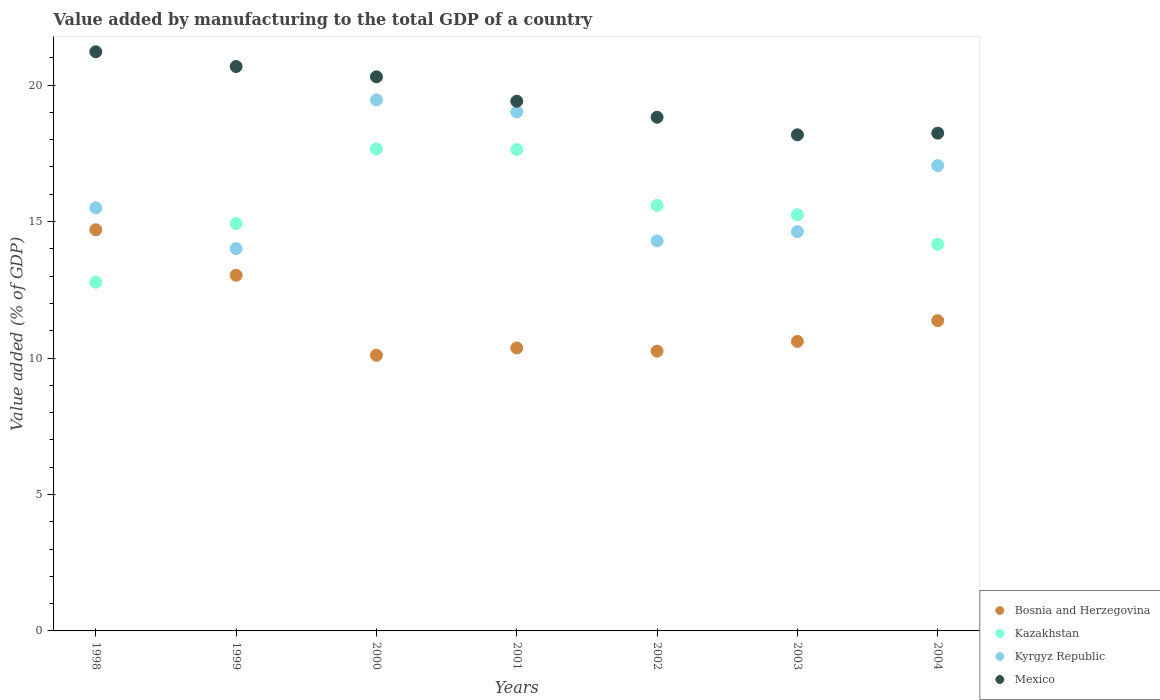What is the value added by manufacturing to the total GDP in Bosnia and Herzegovina in 2002?
Your answer should be very brief. 10.25. Across all years, what is the maximum value added by manufacturing to the total GDP in Bosnia and Herzegovina?
Provide a short and direct response. 14.7. Across all years, what is the minimum value added by manufacturing to the total GDP in Bosnia and Herzegovina?
Give a very brief answer. 10.1. In which year was the value added by manufacturing to the total GDP in Bosnia and Herzegovina maximum?
Provide a succinct answer. 1998. What is the total value added by manufacturing to the total GDP in Mexico in the graph?
Provide a succinct answer. 136.87. What is the difference between the value added by manufacturing to the total GDP in Mexico in 2000 and that in 2003?
Offer a terse response. 2.13. What is the difference between the value added by manufacturing to the total GDP in Bosnia and Herzegovina in 2003 and the value added by manufacturing to the total GDP in Kyrgyz Republic in 1999?
Ensure brevity in your answer.  -3.4. What is the average value added by manufacturing to the total GDP in Mexico per year?
Provide a succinct answer. 19.55. In the year 1998, what is the difference between the value added by manufacturing to the total GDP in Kyrgyz Republic and value added by manufacturing to the total GDP in Mexico?
Provide a succinct answer. -5.72. In how many years, is the value added by manufacturing to the total GDP in Kazakhstan greater than 1 %?
Your answer should be compact. 7. What is the ratio of the value added by manufacturing to the total GDP in Kyrgyz Republic in 2001 to that in 2003?
Offer a very short reply. 1.3. Is the value added by manufacturing to the total GDP in Kazakhstan in 1998 less than that in 2001?
Ensure brevity in your answer.  Yes. What is the difference between the highest and the second highest value added by manufacturing to the total GDP in Bosnia and Herzegovina?
Offer a terse response. 1.67. What is the difference between the highest and the lowest value added by manufacturing to the total GDP in Kyrgyz Republic?
Provide a succinct answer. 5.45. Is it the case that in every year, the sum of the value added by manufacturing to the total GDP in Mexico and value added by manufacturing to the total GDP in Bosnia and Herzegovina  is greater than the sum of value added by manufacturing to the total GDP in Kyrgyz Republic and value added by manufacturing to the total GDP in Kazakhstan?
Your response must be concise. No. Is the value added by manufacturing to the total GDP in Bosnia and Herzegovina strictly greater than the value added by manufacturing to the total GDP in Kazakhstan over the years?
Provide a succinct answer. No. What is the difference between two consecutive major ticks on the Y-axis?
Offer a terse response. 5. Are the values on the major ticks of Y-axis written in scientific E-notation?
Provide a short and direct response. No. Does the graph contain grids?
Your answer should be compact. No. Where does the legend appear in the graph?
Provide a short and direct response. Bottom right. How many legend labels are there?
Ensure brevity in your answer.  4. How are the legend labels stacked?
Provide a short and direct response. Vertical. What is the title of the graph?
Keep it short and to the point. Value added by manufacturing to the total GDP of a country. Does "Bahrain" appear as one of the legend labels in the graph?
Your answer should be compact. No. What is the label or title of the X-axis?
Give a very brief answer. Years. What is the label or title of the Y-axis?
Provide a succinct answer. Value added (% of GDP). What is the Value added (% of GDP) of Bosnia and Herzegovina in 1998?
Your answer should be very brief. 14.7. What is the Value added (% of GDP) in Kazakhstan in 1998?
Offer a terse response. 12.78. What is the Value added (% of GDP) in Kyrgyz Republic in 1998?
Provide a short and direct response. 15.5. What is the Value added (% of GDP) in Mexico in 1998?
Ensure brevity in your answer.  21.22. What is the Value added (% of GDP) in Bosnia and Herzegovina in 1999?
Offer a terse response. 13.03. What is the Value added (% of GDP) in Kazakhstan in 1999?
Your answer should be very brief. 14.93. What is the Value added (% of GDP) in Kyrgyz Republic in 1999?
Provide a short and direct response. 14.01. What is the Value added (% of GDP) of Mexico in 1999?
Ensure brevity in your answer.  20.68. What is the Value added (% of GDP) of Bosnia and Herzegovina in 2000?
Provide a short and direct response. 10.1. What is the Value added (% of GDP) of Kazakhstan in 2000?
Give a very brief answer. 17.66. What is the Value added (% of GDP) of Kyrgyz Republic in 2000?
Offer a very short reply. 19.46. What is the Value added (% of GDP) in Mexico in 2000?
Keep it short and to the point. 20.3. What is the Value added (% of GDP) of Bosnia and Herzegovina in 2001?
Give a very brief answer. 10.37. What is the Value added (% of GDP) of Kazakhstan in 2001?
Provide a succinct answer. 17.64. What is the Value added (% of GDP) of Kyrgyz Republic in 2001?
Give a very brief answer. 19.02. What is the Value added (% of GDP) in Mexico in 2001?
Provide a succinct answer. 19.41. What is the Value added (% of GDP) in Bosnia and Herzegovina in 2002?
Provide a short and direct response. 10.25. What is the Value added (% of GDP) in Kazakhstan in 2002?
Your answer should be compact. 15.59. What is the Value added (% of GDP) of Kyrgyz Republic in 2002?
Offer a terse response. 14.29. What is the Value added (% of GDP) in Mexico in 2002?
Provide a short and direct response. 18.82. What is the Value added (% of GDP) in Bosnia and Herzegovina in 2003?
Offer a terse response. 10.61. What is the Value added (% of GDP) in Kazakhstan in 2003?
Provide a succinct answer. 15.25. What is the Value added (% of GDP) in Kyrgyz Republic in 2003?
Offer a very short reply. 14.63. What is the Value added (% of GDP) in Mexico in 2003?
Give a very brief answer. 18.18. What is the Value added (% of GDP) of Bosnia and Herzegovina in 2004?
Ensure brevity in your answer.  11.37. What is the Value added (% of GDP) of Kazakhstan in 2004?
Your answer should be very brief. 14.17. What is the Value added (% of GDP) in Kyrgyz Republic in 2004?
Offer a very short reply. 17.05. What is the Value added (% of GDP) in Mexico in 2004?
Make the answer very short. 18.24. Across all years, what is the maximum Value added (% of GDP) in Bosnia and Herzegovina?
Provide a short and direct response. 14.7. Across all years, what is the maximum Value added (% of GDP) in Kazakhstan?
Make the answer very short. 17.66. Across all years, what is the maximum Value added (% of GDP) in Kyrgyz Republic?
Keep it short and to the point. 19.46. Across all years, what is the maximum Value added (% of GDP) of Mexico?
Keep it short and to the point. 21.22. Across all years, what is the minimum Value added (% of GDP) of Bosnia and Herzegovina?
Your answer should be compact. 10.1. Across all years, what is the minimum Value added (% of GDP) of Kazakhstan?
Provide a succinct answer. 12.78. Across all years, what is the minimum Value added (% of GDP) in Kyrgyz Republic?
Offer a terse response. 14.01. Across all years, what is the minimum Value added (% of GDP) in Mexico?
Your response must be concise. 18.18. What is the total Value added (% of GDP) of Bosnia and Herzegovina in the graph?
Ensure brevity in your answer.  80.43. What is the total Value added (% of GDP) of Kazakhstan in the graph?
Keep it short and to the point. 108.02. What is the total Value added (% of GDP) of Kyrgyz Republic in the graph?
Ensure brevity in your answer.  113.97. What is the total Value added (% of GDP) of Mexico in the graph?
Provide a short and direct response. 136.87. What is the difference between the Value added (% of GDP) in Bosnia and Herzegovina in 1998 and that in 1999?
Offer a very short reply. 1.67. What is the difference between the Value added (% of GDP) of Kazakhstan in 1998 and that in 1999?
Provide a succinct answer. -2.15. What is the difference between the Value added (% of GDP) of Kyrgyz Republic in 1998 and that in 1999?
Your answer should be very brief. 1.5. What is the difference between the Value added (% of GDP) of Mexico in 1998 and that in 1999?
Make the answer very short. 0.54. What is the difference between the Value added (% of GDP) of Bosnia and Herzegovina in 1998 and that in 2000?
Provide a succinct answer. 4.6. What is the difference between the Value added (% of GDP) in Kazakhstan in 1998 and that in 2000?
Your response must be concise. -4.88. What is the difference between the Value added (% of GDP) in Kyrgyz Republic in 1998 and that in 2000?
Give a very brief answer. -3.96. What is the difference between the Value added (% of GDP) of Mexico in 1998 and that in 2000?
Keep it short and to the point. 0.92. What is the difference between the Value added (% of GDP) of Bosnia and Herzegovina in 1998 and that in 2001?
Your answer should be very brief. 4.33. What is the difference between the Value added (% of GDP) of Kazakhstan in 1998 and that in 2001?
Ensure brevity in your answer.  -4.86. What is the difference between the Value added (% of GDP) in Kyrgyz Republic in 1998 and that in 2001?
Offer a terse response. -3.52. What is the difference between the Value added (% of GDP) in Mexico in 1998 and that in 2001?
Provide a succinct answer. 1.81. What is the difference between the Value added (% of GDP) of Bosnia and Herzegovina in 1998 and that in 2002?
Keep it short and to the point. 4.45. What is the difference between the Value added (% of GDP) of Kazakhstan in 1998 and that in 2002?
Offer a terse response. -2.82. What is the difference between the Value added (% of GDP) of Kyrgyz Republic in 1998 and that in 2002?
Make the answer very short. 1.21. What is the difference between the Value added (% of GDP) in Mexico in 1998 and that in 2002?
Your response must be concise. 2.4. What is the difference between the Value added (% of GDP) of Bosnia and Herzegovina in 1998 and that in 2003?
Give a very brief answer. 4.09. What is the difference between the Value added (% of GDP) of Kazakhstan in 1998 and that in 2003?
Your answer should be very brief. -2.48. What is the difference between the Value added (% of GDP) of Kyrgyz Republic in 1998 and that in 2003?
Offer a very short reply. 0.87. What is the difference between the Value added (% of GDP) of Mexico in 1998 and that in 2003?
Provide a succinct answer. 3.04. What is the difference between the Value added (% of GDP) of Bosnia and Herzegovina in 1998 and that in 2004?
Your response must be concise. 3.33. What is the difference between the Value added (% of GDP) in Kazakhstan in 1998 and that in 2004?
Your answer should be very brief. -1.39. What is the difference between the Value added (% of GDP) of Kyrgyz Republic in 1998 and that in 2004?
Your answer should be compact. -1.55. What is the difference between the Value added (% of GDP) in Mexico in 1998 and that in 2004?
Offer a very short reply. 2.98. What is the difference between the Value added (% of GDP) of Bosnia and Herzegovina in 1999 and that in 2000?
Make the answer very short. 2.93. What is the difference between the Value added (% of GDP) in Kazakhstan in 1999 and that in 2000?
Ensure brevity in your answer.  -2.73. What is the difference between the Value added (% of GDP) of Kyrgyz Republic in 1999 and that in 2000?
Offer a very short reply. -5.45. What is the difference between the Value added (% of GDP) of Mexico in 1999 and that in 2000?
Your answer should be very brief. 0.38. What is the difference between the Value added (% of GDP) in Bosnia and Herzegovina in 1999 and that in 2001?
Provide a short and direct response. 2.66. What is the difference between the Value added (% of GDP) in Kazakhstan in 1999 and that in 2001?
Your answer should be very brief. -2.71. What is the difference between the Value added (% of GDP) in Kyrgyz Republic in 1999 and that in 2001?
Offer a very short reply. -5.01. What is the difference between the Value added (% of GDP) of Mexico in 1999 and that in 2001?
Provide a short and direct response. 1.27. What is the difference between the Value added (% of GDP) of Bosnia and Herzegovina in 1999 and that in 2002?
Your response must be concise. 2.78. What is the difference between the Value added (% of GDP) of Kazakhstan in 1999 and that in 2002?
Make the answer very short. -0.67. What is the difference between the Value added (% of GDP) of Kyrgyz Republic in 1999 and that in 2002?
Give a very brief answer. -0.28. What is the difference between the Value added (% of GDP) in Mexico in 1999 and that in 2002?
Your answer should be compact. 1.86. What is the difference between the Value added (% of GDP) in Bosnia and Herzegovina in 1999 and that in 2003?
Provide a succinct answer. 2.42. What is the difference between the Value added (% of GDP) of Kazakhstan in 1999 and that in 2003?
Provide a short and direct response. -0.32. What is the difference between the Value added (% of GDP) in Kyrgyz Republic in 1999 and that in 2003?
Provide a short and direct response. -0.62. What is the difference between the Value added (% of GDP) in Mexico in 1999 and that in 2003?
Keep it short and to the point. 2.5. What is the difference between the Value added (% of GDP) in Bosnia and Herzegovina in 1999 and that in 2004?
Provide a short and direct response. 1.66. What is the difference between the Value added (% of GDP) of Kazakhstan in 1999 and that in 2004?
Ensure brevity in your answer.  0.76. What is the difference between the Value added (% of GDP) of Kyrgyz Republic in 1999 and that in 2004?
Offer a terse response. -3.04. What is the difference between the Value added (% of GDP) in Mexico in 1999 and that in 2004?
Ensure brevity in your answer.  2.44. What is the difference between the Value added (% of GDP) in Bosnia and Herzegovina in 2000 and that in 2001?
Make the answer very short. -0.27. What is the difference between the Value added (% of GDP) of Kazakhstan in 2000 and that in 2001?
Provide a short and direct response. 0.02. What is the difference between the Value added (% of GDP) in Kyrgyz Republic in 2000 and that in 2001?
Ensure brevity in your answer.  0.44. What is the difference between the Value added (% of GDP) in Mexico in 2000 and that in 2001?
Your response must be concise. 0.89. What is the difference between the Value added (% of GDP) of Bosnia and Herzegovina in 2000 and that in 2002?
Provide a short and direct response. -0.15. What is the difference between the Value added (% of GDP) of Kazakhstan in 2000 and that in 2002?
Provide a short and direct response. 2.07. What is the difference between the Value added (% of GDP) in Kyrgyz Republic in 2000 and that in 2002?
Ensure brevity in your answer.  5.17. What is the difference between the Value added (% of GDP) of Mexico in 2000 and that in 2002?
Your answer should be very brief. 1.48. What is the difference between the Value added (% of GDP) in Bosnia and Herzegovina in 2000 and that in 2003?
Ensure brevity in your answer.  -0.51. What is the difference between the Value added (% of GDP) of Kazakhstan in 2000 and that in 2003?
Make the answer very short. 2.41. What is the difference between the Value added (% of GDP) of Kyrgyz Republic in 2000 and that in 2003?
Your answer should be very brief. 4.83. What is the difference between the Value added (% of GDP) of Mexico in 2000 and that in 2003?
Provide a succinct answer. 2.13. What is the difference between the Value added (% of GDP) in Bosnia and Herzegovina in 2000 and that in 2004?
Offer a very short reply. -1.27. What is the difference between the Value added (% of GDP) of Kazakhstan in 2000 and that in 2004?
Make the answer very short. 3.49. What is the difference between the Value added (% of GDP) of Kyrgyz Republic in 2000 and that in 2004?
Your response must be concise. 2.41. What is the difference between the Value added (% of GDP) of Mexico in 2000 and that in 2004?
Offer a very short reply. 2.06. What is the difference between the Value added (% of GDP) in Bosnia and Herzegovina in 2001 and that in 2002?
Offer a very short reply. 0.12. What is the difference between the Value added (% of GDP) in Kazakhstan in 2001 and that in 2002?
Keep it short and to the point. 2.04. What is the difference between the Value added (% of GDP) in Kyrgyz Republic in 2001 and that in 2002?
Offer a terse response. 4.73. What is the difference between the Value added (% of GDP) of Mexico in 2001 and that in 2002?
Provide a succinct answer. 0.59. What is the difference between the Value added (% of GDP) of Bosnia and Herzegovina in 2001 and that in 2003?
Your response must be concise. -0.24. What is the difference between the Value added (% of GDP) in Kazakhstan in 2001 and that in 2003?
Offer a terse response. 2.39. What is the difference between the Value added (% of GDP) in Kyrgyz Republic in 2001 and that in 2003?
Provide a short and direct response. 4.39. What is the difference between the Value added (% of GDP) in Mexico in 2001 and that in 2003?
Make the answer very short. 1.23. What is the difference between the Value added (% of GDP) of Bosnia and Herzegovina in 2001 and that in 2004?
Ensure brevity in your answer.  -1. What is the difference between the Value added (% of GDP) in Kazakhstan in 2001 and that in 2004?
Your answer should be very brief. 3.47. What is the difference between the Value added (% of GDP) in Kyrgyz Republic in 2001 and that in 2004?
Your answer should be compact. 1.97. What is the difference between the Value added (% of GDP) in Mexico in 2001 and that in 2004?
Make the answer very short. 1.17. What is the difference between the Value added (% of GDP) in Bosnia and Herzegovina in 2002 and that in 2003?
Offer a terse response. -0.36. What is the difference between the Value added (% of GDP) of Kazakhstan in 2002 and that in 2003?
Keep it short and to the point. 0.34. What is the difference between the Value added (% of GDP) of Kyrgyz Republic in 2002 and that in 2003?
Provide a succinct answer. -0.34. What is the difference between the Value added (% of GDP) in Mexico in 2002 and that in 2003?
Your answer should be very brief. 0.64. What is the difference between the Value added (% of GDP) of Bosnia and Herzegovina in 2002 and that in 2004?
Ensure brevity in your answer.  -1.12. What is the difference between the Value added (% of GDP) in Kazakhstan in 2002 and that in 2004?
Offer a terse response. 1.43. What is the difference between the Value added (% of GDP) of Kyrgyz Republic in 2002 and that in 2004?
Provide a short and direct response. -2.76. What is the difference between the Value added (% of GDP) of Mexico in 2002 and that in 2004?
Ensure brevity in your answer.  0.58. What is the difference between the Value added (% of GDP) in Bosnia and Herzegovina in 2003 and that in 2004?
Keep it short and to the point. -0.76. What is the difference between the Value added (% of GDP) of Kazakhstan in 2003 and that in 2004?
Provide a short and direct response. 1.09. What is the difference between the Value added (% of GDP) of Kyrgyz Republic in 2003 and that in 2004?
Make the answer very short. -2.42. What is the difference between the Value added (% of GDP) of Mexico in 2003 and that in 2004?
Your answer should be compact. -0.06. What is the difference between the Value added (% of GDP) in Bosnia and Herzegovina in 1998 and the Value added (% of GDP) in Kazakhstan in 1999?
Your response must be concise. -0.23. What is the difference between the Value added (% of GDP) of Bosnia and Herzegovina in 1998 and the Value added (% of GDP) of Kyrgyz Republic in 1999?
Give a very brief answer. 0.69. What is the difference between the Value added (% of GDP) in Bosnia and Herzegovina in 1998 and the Value added (% of GDP) in Mexico in 1999?
Make the answer very short. -5.98. What is the difference between the Value added (% of GDP) of Kazakhstan in 1998 and the Value added (% of GDP) of Kyrgyz Republic in 1999?
Make the answer very short. -1.23. What is the difference between the Value added (% of GDP) in Kazakhstan in 1998 and the Value added (% of GDP) in Mexico in 1999?
Provide a succinct answer. -7.91. What is the difference between the Value added (% of GDP) in Kyrgyz Republic in 1998 and the Value added (% of GDP) in Mexico in 1999?
Your response must be concise. -5.18. What is the difference between the Value added (% of GDP) of Bosnia and Herzegovina in 1998 and the Value added (% of GDP) of Kazakhstan in 2000?
Provide a succinct answer. -2.96. What is the difference between the Value added (% of GDP) of Bosnia and Herzegovina in 1998 and the Value added (% of GDP) of Kyrgyz Republic in 2000?
Your response must be concise. -4.76. What is the difference between the Value added (% of GDP) of Bosnia and Herzegovina in 1998 and the Value added (% of GDP) of Mexico in 2000?
Offer a very short reply. -5.6. What is the difference between the Value added (% of GDP) of Kazakhstan in 1998 and the Value added (% of GDP) of Kyrgyz Republic in 2000?
Your answer should be compact. -6.68. What is the difference between the Value added (% of GDP) of Kazakhstan in 1998 and the Value added (% of GDP) of Mexico in 2000?
Ensure brevity in your answer.  -7.53. What is the difference between the Value added (% of GDP) of Kyrgyz Republic in 1998 and the Value added (% of GDP) of Mexico in 2000?
Provide a succinct answer. -4.8. What is the difference between the Value added (% of GDP) in Bosnia and Herzegovina in 1998 and the Value added (% of GDP) in Kazakhstan in 2001?
Provide a short and direct response. -2.94. What is the difference between the Value added (% of GDP) in Bosnia and Herzegovina in 1998 and the Value added (% of GDP) in Kyrgyz Republic in 2001?
Offer a terse response. -4.32. What is the difference between the Value added (% of GDP) in Bosnia and Herzegovina in 1998 and the Value added (% of GDP) in Mexico in 2001?
Your response must be concise. -4.71. What is the difference between the Value added (% of GDP) in Kazakhstan in 1998 and the Value added (% of GDP) in Kyrgyz Republic in 2001?
Your answer should be compact. -6.24. What is the difference between the Value added (% of GDP) in Kazakhstan in 1998 and the Value added (% of GDP) in Mexico in 2001?
Keep it short and to the point. -6.63. What is the difference between the Value added (% of GDP) of Kyrgyz Republic in 1998 and the Value added (% of GDP) of Mexico in 2001?
Keep it short and to the point. -3.91. What is the difference between the Value added (% of GDP) in Bosnia and Herzegovina in 1998 and the Value added (% of GDP) in Kazakhstan in 2002?
Provide a succinct answer. -0.89. What is the difference between the Value added (% of GDP) in Bosnia and Herzegovina in 1998 and the Value added (% of GDP) in Kyrgyz Republic in 2002?
Offer a very short reply. 0.41. What is the difference between the Value added (% of GDP) of Bosnia and Herzegovina in 1998 and the Value added (% of GDP) of Mexico in 2002?
Your response must be concise. -4.12. What is the difference between the Value added (% of GDP) in Kazakhstan in 1998 and the Value added (% of GDP) in Kyrgyz Republic in 2002?
Your answer should be compact. -1.51. What is the difference between the Value added (% of GDP) in Kazakhstan in 1998 and the Value added (% of GDP) in Mexico in 2002?
Your answer should be compact. -6.05. What is the difference between the Value added (% of GDP) of Kyrgyz Republic in 1998 and the Value added (% of GDP) of Mexico in 2002?
Make the answer very short. -3.32. What is the difference between the Value added (% of GDP) in Bosnia and Herzegovina in 1998 and the Value added (% of GDP) in Kazakhstan in 2003?
Make the answer very short. -0.55. What is the difference between the Value added (% of GDP) in Bosnia and Herzegovina in 1998 and the Value added (% of GDP) in Kyrgyz Republic in 2003?
Your response must be concise. 0.07. What is the difference between the Value added (% of GDP) in Bosnia and Herzegovina in 1998 and the Value added (% of GDP) in Mexico in 2003?
Make the answer very short. -3.48. What is the difference between the Value added (% of GDP) of Kazakhstan in 1998 and the Value added (% of GDP) of Kyrgyz Republic in 2003?
Keep it short and to the point. -1.86. What is the difference between the Value added (% of GDP) in Kazakhstan in 1998 and the Value added (% of GDP) in Mexico in 2003?
Offer a terse response. -5.4. What is the difference between the Value added (% of GDP) in Kyrgyz Republic in 1998 and the Value added (% of GDP) in Mexico in 2003?
Your answer should be very brief. -2.68. What is the difference between the Value added (% of GDP) in Bosnia and Herzegovina in 1998 and the Value added (% of GDP) in Kazakhstan in 2004?
Make the answer very short. 0.53. What is the difference between the Value added (% of GDP) of Bosnia and Herzegovina in 1998 and the Value added (% of GDP) of Kyrgyz Republic in 2004?
Give a very brief answer. -2.35. What is the difference between the Value added (% of GDP) in Bosnia and Herzegovina in 1998 and the Value added (% of GDP) in Mexico in 2004?
Your answer should be very brief. -3.54. What is the difference between the Value added (% of GDP) in Kazakhstan in 1998 and the Value added (% of GDP) in Kyrgyz Republic in 2004?
Offer a terse response. -4.28. What is the difference between the Value added (% of GDP) in Kazakhstan in 1998 and the Value added (% of GDP) in Mexico in 2004?
Offer a terse response. -5.46. What is the difference between the Value added (% of GDP) in Kyrgyz Republic in 1998 and the Value added (% of GDP) in Mexico in 2004?
Provide a short and direct response. -2.74. What is the difference between the Value added (% of GDP) in Bosnia and Herzegovina in 1999 and the Value added (% of GDP) in Kazakhstan in 2000?
Keep it short and to the point. -4.63. What is the difference between the Value added (% of GDP) of Bosnia and Herzegovina in 1999 and the Value added (% of GDP) of Kyrgyz Republic in 2000?
Provide a succinct answer. -6.43. What is the difference between the Value added (% of GDP) of Bosnia and Herzegovina in 1999 and the Value added (% of GDP) of Mexico in 2000?
Your answer should be very brief. -7.27. What is the difference between the Value added (% of GDP) of Kazakhstan in 1999 and the Value added (% of GDP) of Kyrgyz Republic in 2000?
Provide a short and direct response. -4.53. What is the difference between the Value added (% of GDP) of Kazakhstan in 1999 and the Value added (% of GDP) of Mexico in 2000?
Keep it short and to the point. -5.38. What is the difference between the Value added (% of GDP) of Kyrgyz Republic in 1999 and the Value added (% of GDP) of Mexico in 2000?
Provide a short and direct response. -6.3. What is the difference between the Value added (% of GDP) of Bosnia and Herzegovina in 1999 and the Value added (% of GDP) of Kazakhstan in 2001?
Your response must be concise. -4.61. What is the difference between the Value added (% of GDP) in Bosnia and Herzegovina in 1999 and the Value added (% of GDP) in Kyrgyz Republic in 2001?
Make the answer very short. -5.99. What is the difference between the Value added (% of GDP) of Bosnia and Herzegovina in 1999 and the Value added (% of GDP) of Mexico in 2001?
Give a very brief answer. -6.38. What is the difference between the Value added (% of GDP) in Kazakhstan in 1999 and the Value added (% of GDP) in Kyrgyz Republic in 2001?
Your answer should be very brief. -4.09. What is the difference between the Value added (% of GDP) of Kazakhstan in 1999 and the Value added (% of GDP) of Mexico in 2001?
Your answer should be compact. -4.48. What is the difference between the Value added (% of GDP) of Kyrgyz Republic in 1999 and the Value added (% of GDP) of Mexico in 2001?
Give a very brief answer. -5.4. What is the difference between the Value added (% of GDP) of Bosnia and Herzegovina in 1999 and the Value added (% of GDP) of Kazakhstan in 2002?
Offer a very short reply. -2.56. What is the difference between the Value added (% of GDP) in Bosnia and Herzegovina in 1999 and the Value added (% of GDP) in Kyrgyz Republic in 2002?
Provide a short and direct response. -1.26. What is the difference between the Value added (% of GDP) in Bosnia and Herzegovina in 1999 and the Value added (% of GDP) in Mexico in 2002?
Keep it short and to the point. -5.79. What is the difference between the Value added (% of GDP) of Kazakhstan in 1999 and the Value added (% of GDP) of Kyrgyz Republic in 2002?
Provide a short and direct response. 0.64. What is the difference between the Value added (% of GDP) of Kazakhstan in 1999 and the Value added (% of GDP) of Mexico in 2002?
Provide a succinct answer. -3.89. What is the difference between the Value added (% of GDP) of Kyrgyz Republic in 1999 and the Value added (% of GDP) of Mexico in 2002?
Your response must be concise. -4.82. What is the difference between the Value added (% of GDP) of Bosnia and Herzegovina in 1999 and the Value added (% of GDP) of Kazakhstan in 2003?
Your answer should be compact. -2.22. What is the difference between the Value added (% of GDP) of Bosnia and Herzegovina in 1999 and the Value added (% of GDP) of Kyrgyz Republic in 2003?
Keep it short and to the point. -1.6. What is the difference between the Value added (% of GDP) of Bosnia and Herzegovina in 1999 and the Value added (% of GDP) of Mexico in 2003?
Your answer should be compact. -5.15. What is the difference between the Value added (% of GDP) in Kazakhstan in 1999 and the Value added (% of GDP) in Kyrgyz Republic in 2003?
Offer a terse response. 0.3. What is the difference between the Value added (% of GDP) of Kazakhstan in 1999 and the Value added (% of GDP) of Mexico in 2003?
Make the answer very short. -3.25. What is the difference between the Value added (% of GDP) in Kyrgyz Republic in 1999 and the Value added (% of GDP) in Mexico in 2003?
Offer a terse response. -4.17. What is the difference between the Value added (% of GDP) of Bosnia and Herzegovina in 1999 and the Value added (% of GDP) of Kazakhstan in 2004?
Keep it short and to the point. -1.13. What is the difference between the Value added (% of GDP) in Bosnia and Herzegovina in 1999 and the Value added (% of GDP) in Kyrgyz Republic in 2004?
Keep it short and to the point. -4.02. What is the difference between the Value added (% of GDP) of Bosnia and Herzegovina in 1999 and the Value added (% of GDP) of Mexico in 2004?
Offer a terse response. -5.21. What is the difference between the Value added (% of GDP) of Kazakhstan in 1999 and the Value added (% of GDP) of Kyrgyz Republic in 2004?
Offer a terse response. -2.12. What is the difference between the Value added (% of GDP) of Kazakhstan in 1999 and the Value added (% of GDP) of Mexico in 2004?
Give a very brief answer. -3.31. What is the difference between the Value added (% of GDP) in Kyrgyz Republic in 1999 and the Value added (% of GDP) in Mexico in 2004?
Ensure brevity in your answer.  -4.23. What is the difference between the Value added (% of GDP) of Bosnia and Herzegovina in 2000 and the Value added (% of GDP) of Kazakhstan in 2001?
Make the answer very short. -7.54. What is the difference between the Value added (% of GDP) in Bosnia and Herzegovina in 2000 and the Value added (% of GDP) in Kyrgyz Republic in 2001?
Ensure brevity in your answer.  -8.92. What is the difference between the Value added (% of GDP) in Bosnia and Herzegovina in 2000 and the Value added (% of GDP) in Mexico in 2001?
Ensure brevity in your answer.  -9.31. What is the difference between the Value added (% of GDP) in Kazakhstan in 2000 and the Value added (% of GDP) in Kyrgyz Republic in 2001?
Your response must be concise. -1.36. What is the difference between the Value added (% of GDP) of Kazakhstan in 2000 and the Value added (% of GDP) of Mexico in 2001?
Provide a short and direct response. -1.75. What is the difference between the Value added (% of GDP) in Kyrgyz Republic in 2000 and the Value added (% of GDP) in Mexico in 2001?
Your answer should be very brief. 0.05. What is the difference between the Value added (% of GDP) of Bosnia and Herzegovina in 2000 and the Value added (% of GDP) of Kazakhstan in 2002?
Provide a succinct answer. -5.49. What is the difference between the Value added (% of GDP) of Bosnia and Herzegovina in 2000 and the Value added (% of GDP) of Kyrgyz Republic in 2002?
Offer a terse response. -4.19. What is the difference between the Value added (% of GDP) in Bosnia and Herzegovina in 2000 and the Value added (% of GDP) in Mexico in 2002?
Your response must be concise. -8.72. What is the difference between the Value added (% of GDP) in Kazakhstan in 2000 and the Value added (% of GDP) in Kyrgyz Republic in 2002?
Provide a succinct answer. 3.37. What is the difference between the Value added (% of GDP) in Kazakhstan in 2000 and the Value added (% of GDP) in Mexico in 2002?
Provide a short and direct response. -1.16. What is the difference between the Value added (% of GDP) of Kyrgyz Republic in 2000 and the Value added (% of GDP) of Mexico in 2002?
Provide a succinct answer. 0.63. What is the difference between the Value added (% of GDP) in Bosnia and Herzegovina in 2000 and the Value added (% of GDP) in Kazakhstan in 2003?
Offer a very short reply. -5.15. What is the difference between the Value added (% of GDP) in Bosnia and Herzegovina in 2000 and the Value added (% of GDP) in Kyrgyz Republic in 2003?
Provide a succinct answer. -4.53. What is the difference between the Value added (% of GDP) in Bosnia and Herzegovina in 2000 and the Value added (% of GDP) in Mexico in 2003?
Provide a succinct answer. -8.08. What is the difference between the Value added (% of GDP) in Kazakhstan in 2000 and the Value added (% of GDP) in Kyrgyz Republic in 2003?
Your answer should be very brief. 3.03. What is the difference between the Value added (% of GDP) in Kazakhstan in 2000 and the Value added (% of GDP) in Mexico in 2003?
Offer a very short reply. -0.52. What is the difference between the Value added (% of GDP) in Kyrgyz Republic in 2000 and the Value added (% of GDP) in Mexico in 2003?
Give a very brief answer. 1.28. What is the difference between the Value added (% of GDP) of Bosnia and Herzegovina in 2000 and the Value added (% of GDP) of Kazakhstan in 2004?
Provide a short and direct response. -4.07. What is the difference between the Value added (% of GDP) of Bosnia and Herzegovina in 2000 and the Value added (% of GDP) of Kyrgyz Republic in 2004?
Ensure brevity in your answer.  -6.95. What is the difference between the Value added (% of GDP) in Bosnia and Herzegovina in 2000 and the Value added (% of GDP) in Mexico in 2004?
Make the answer very short. -8.14. What is the difference between the Value added (% of GDP) of Kazakhstan in 2000 and the Value added (% of GDP) of Kyrgyz Republic in 2004?
Give a very brief answer. 0.61. What is the difference between the Value added (% of GDP) in Kazakhstan in 2000 and the Value added (% of GDP) in Mexico in 2004?
Provide a short and direct response. -0.58. What is the difference between the Value added (% of GDP) in Kyrgyz Republic in 2000 and the Value added (% of GDP) in Mexico in 2004?
Offer a very short reply. 1.22. What is the difference between the Value added (% of GDP) in Bosnia and Herzegovina in 2001 and the Value added (% of GDP) in Kazakhstan in 2002?
Your answer should be very brief. -5.23. What is the difference between the Value added (% of GDP) in Bosnia and Herzegovina in 2001 and the Value added (% of GDP) in Kyrgyz Republic in 2002?
Make the answer very short. -3.92. What is the difference between the Value added (% of GDP) of Bosnia and Herzegovina in 2001 and the Value added (% of GDP) of Mexico in 2002?
Your answer should be compact. -8.46. What is the difference between the Value added (% of GDP) in Kazakhstan in 2001 and the Value added (% of GDP) in Kyrgyz Republic in 2002?
Make the answer very short. 3.35. What is the difference between the Value added (% of GDP) of Kazakhstan in 2001 and the Value added (% of GDP) of Mexico in 2002?
Offer a terse response. -1.18. What is the difference between the Value added (% of GDP) of Kyrgyz Republic in 2001 and the Value added (% of GDP) of Mexico in 2002?
Your answer should be very brief. 0.2. What is the difference between the Value added (% of GDP) of Bosnia and Herzegovina in 2001 and the Value added (% of GDP) of Kazakhstan in 2003?
Offer a very short reply. -4.88. What is the difference between the Value added (% of GDP) in Bosnia and Herzegovina in 2001 and the Value added (% of GDP) in Kyrgyz Republic in 2003?
Your response must be concise. -4.27. What is the difference between the Value added (% of GDP) of Bosnia and Herzegovina in 2001 and the Value added (% of GDP) of Mexico in 2003?
Your answer should be very brief. -7.81. What is the difference between the Value added (% of GDP) in Kazakhstan in 2001 and the Value added (% of GDP) in Kyrgyz Republic in 2003?
Your answer should be compact. 3.01. What is the difference between the Value added (% of GDP) of Kazakhstan in 2001 and the Value added (% of GDP) of Mexico in 2003?
Your response must be concise. -0.54. What is the difference between the Value added (% of GDP) of Kyrgyz Republic in 2001 and the Value added (% of GDP) of Mexico in 2003?
Keep it short and to the point. 0.84. What is the difference between the Value added (% of GDP) of Bosnia and Herzegovina in 2001 and the Value added (% of GDP) of Kazakhstan in 2004?
Your answer should be very brief. -3.8. What is the difference between the Value added (% of GDP) in Bosnia and Herzegovina in 2001 and the Value added (% of GDP) in Kyrgyz Republic in 2004?
Ensure brevity in your answer.  -6.68. What is the difference between the Value added (% of GDP) of Bosnia and Herzegovina in 2001 and the Value added (% of GDP) of Mexico in 2004?
Make the answer very short. -7.87. What is the difference between the Value added (% of GDP) of Kazakhstan in 2001 and the Value added (% of GDP) of Kyrgyz Republic in 2004?
Keep it short and to the point. 0.59. What is the difference between the Value added (% of GDP) in Kazakhstan in 2001 and the Value added (% of GDP) in Mexico in 2004?
Keep it short and to the point. -0.6. What is the difference between the Value added (% of GDP) of Kyrgyz Republic in 2001 and the Value added (% of GDP) of Mexico in 2004?
Your answer should be compact. 0.78. What is the difference between the Value added (% of GDP) in Bosnia and Herzegovina in 2002 and the Value added (% of GDP) in Kazakhstan in 2003?
Ensure brevity in your answer.  -5. What is the difference between the Value added (% of GDP) in Bosnia and Herzegovina in 2002 and the Value added (% of GDP) in Kyrgyz Republic in 2003?
Give a very brief answer. -4.38. What is the difference between the Value added (% of GDP) in Bosnia and Herzegovina in 2002 and the Value added (% of GDP) in Mexico in 2003?
Provide a short and direct response. -7.93. What is the difference between the Value added (% of GDP) in Kazakhstan in 2002 and the Value added (% of GDP) in Kyrgyz Republic in 2003?
Your response must be concise. 0.96. What is the difference between the Value added (% of GDP) of Kazakhstan in 2002 and the Value added (% of GDP) of Mexico in 2003?
Give a very brief answer. -2.58. What is the difference between the Value added (% of GDP) in Kyrgyz Republic in 2002 and the Value added (% of GDP) in Mexico in 2003?
Keep it short and to the point. -3.89. What is the difference between the Value added (% of GDP) of Bosnia and Herzegovina in 2002 and the Value added (% of GDP) of Kazakhstan in 2004?
Give a very brief answer. -3.92. What is the difference between the Value added (% of GDP) in Bosnia and Herzegovina in 2002 and the Value added (% of GDP) in Kyrgyz Republic in 2004?
Provide a short and direct response. -6.8. What is the difference between the Value added (% of GDP) of Bosnia and Herzegovina in 2002 and the Value added (% of GDP) of Mexico in 2004?
Provide a short and direct response. -7.99. What is the difference between the Value added (% of GDP) in Kazakhstan in 2002 and the Value added (% of GDP) in Kyrgyz Republic in 2004?
Your response must be concise. -1.46. What is the difference between the Value added (% of GDP) in Kazakhstan in 2002 and the Value added (% of GDP) in Mexico in 2004?
Provide a short and direct response. -2.65. What is the difference between the Value added (% of GDP) in Kyrgyz Republic in 2002 and the Value added (% of GDP) in Mexico in 2004?
Offer a very short reply. -3.95. What is the difference between the Value added (% of GDP) of Bosnia and Herzegovina in 2003 and the Value added (% of GDP) of Kazakhstan in 2004?
Your response must be concise. -3.56. What is the difference between the Value added (% of GDP) of Bosnia and Herzegovina in 2003 and the Value added (% of GDP) of Kyrgyz Republic in 2004?
Your answer should be compact. -6.44. What is the difference between the Value added (% of GDP) of Bosnia and Herzegovina in 2003 and the Value added (% of GDP) of Mexico in 2004?
Provide a succinct answer. -7.63. What is the difference between the Value added (% of GDP) in Kazakhstan in 2003 and the Value added (% of GDP) in Kyrgyz Republic in 2004?
Offer a terse response. -1.8. What is the difference between the Value added (% of GDP) in Kazakhstan in 2003 and the Value added (% of GDP) in Mexico in 2004?
Your answer should be compact. -2.99. What is the difference between the Value added (% of GDP) in Kyrgyz Republic in 2003 and the Value added (% of GDP) in Mexico in 2004?
Give a very brief answer. -3.61. What is the average Value added (% of GDP) in Bosnia and Herzegovina per year?
Your answer should be compact. 11.49. What is the average Value added (% of GDP) in Kazakhstan per year?
Offer a very short reply. 15.43. What is the average Value added (% of GDP) in Kyrgyz Republic per year?
Offer a terse response. 16.28. What is the average Value added (% of GDP) in Mexico per year?
Offer a very short reply. 19.55. In the year 1998, what is the difference between the Value added (% of GDP) of Bosnia and Herzegovina and Value added (% of GDP) of Kazakhstan?
Offer a very short reply. 1.92. In the year 1998, what is the difference between the Value added (% of GDP) in Bosnia and Herzegovina and Value added (% of GDP) in Kyrgyz Republic?
Make the answer very short. -0.8. In the year 1998, what is the difference between the Value added (% of GDP) of Bosnia and Herzegovina and Value added (% of GDP) of Mexico?
Your answer should be very brief. -6.52. In the year 1998, what is the difference between the Value added (% of GDP) of Kazakhstan and Value added (% of GDP) of Kyrgyz Republic?
Your answer should be very brief. -2.73. In the year 1998, what is the difference between the Value added (% of GDP) in Kazakhstan and Value added (% of GDP) in Mexico?
Your answer should be compact. -8.45. In the year 1998, what is the difference between the Value added (% of GDP) of Kyrgyz Republic and Value added (% of GDP) of Mexico?
Offer a very short reply. -5.72. In the year 1999, what is the difference between the Value added (% of GDP) in Bosnia and Herzegovina and Value added (% of GDP) in Kazakhstan?
Your response must be concise. -1.9. In the year 1999, what is the difference between the Value added (% of GDP) in Bosnia and Herzegovina and Value added (% of GDP) in Kyrgyz Republic?
Ensure brevity in your answer.  -0.98. In the year 1999, what is the difference between the Value added (% of GDP) in Bosnia and Herzegovina and Value added (% of GDP) in Mexico?
Make the answer very short. -7.65. In the year 1999, what is the difference between the Value added (% of GDP) in Kazakhstan and Value added (% of GDP) in Kyrgyz Republic?
Your answer should be compact. 0.92. In the year 1999, what is the difference between the Value added (% of GDP) of Kazakhstan and Value added (% of GDP) of Mexico?
Provide a short and direct response. -5.75. In the year 1999, what is the difference between the Value added (% of GDP) of Kyrgyz Republic and Value added (% of GDP) of Mexico?
Offer a very short reply. -6.67. In the year 2000, what is the difference between the Value added (% of GDP) of Bosnia and Herzegovina and Value added (% of GDP) of Kazakhstan?
Your answer should be very brief. -7.56. In the year 2000, what is the difference between the Value added (% of GDP) of Bosnia and Herzegovina and Value added (% of GDP) of Kyrgyz Republic?
Offer a terse response. -9.36. In the year 2000, what is the difference between the Value added (% of GDP) in Bosnia and Herzegovina and Value added (% of GDP) in Mexico?
Provide a succinct answer. -10.2. In the year 2000, what is the difference between the Value added (% of GDP) in Kazakhstan and Value added (% of GDP) in Kyrgyz Republic?
Your answer should be compact. -1.8. In the year 2000, what is the difference between the Value added (% of GDP) of Kazakhstan and Value added (% of GDP) of Mexico?
Offer a very short reply. -2.64. In the year 2000, what is the difference between the Value added (% of GDP) in Kyrgyz Republic and Value added (% of GDP) in Mexico?
Offer a very short reply. -0.85. In the year 2001, what is the difference between the Value added (% of GDP) in Bosnia and Herzegovina and Value added (% of GDP) in Kazakhstan?
Your response must be concise. -7.27. In the year 2001, what is the difference between the Value added (% of GDP) of Bosnia and Herzegovina and Value added (% of GDP) of Kyrgyz Republic?
Your response must be concise. -8.65. In the year 2001, what is the difference between the Value added (% of GDP) in Bosnia and Herzegovina and Value added (% of GDP) in Mexico?
Ensure brevity in your answer.  -9.04. In the year 2001, what is the difference between the Value added (% of GDP) in Kazakhstan and Value added (% of GDP) in Kyrgyz Republic?
Provide a short and direct response. -1.38. In the year 2001, what is the difference between the Value added (% of GDP) in Kazakhstan and Value added (% of GDP) in Mexico?
Provide a succinct answer. -1.77. In the year 2001, what is the difference between the Value added (% of GDP) in Kyrgyz Republic and Value added (% of GDP) in Mexico?
Your response must be concise. -0.39. In the year 2002, what is the difference between the Value added (% of GDP) in Bosnia and Herzegovina and Value added (% of GDP) in Kazakhstan?
Your response must be concise. -5.34. In the year 2002, what is the difference between the Value added (% of GDP) in Bosnia and Herzegovina and Value added (% of GDP) in Kyrgyz Republic?
Keep it short and to the point. -4.04. In the year 2002, what is the difference between the Value added (% of GDP) of Bosnia and Herzegovina and Value added (% of GDP) of Mexico?
Offer a very short reply. -8.57. In the year 2002, what is the difference between the Value added (% of GDP) in Kazakhstan and Value added (% of GDP) in Kyrgyz Republic?
Offer a very short reply. 1.3. In the year 2002, what is the difference between the Value added (% of GDP) in Kazakhstan and Value added (% of GDP) in Mexico?
Make the answer very short. -3.23. In the year 2002, what is the difference between the Value added (% of GDP) of Kyrgyz Republic and Value added (% of GDP) of Mexico?
Ensure brevity in your answer.  -4.53. In the year 2003, what is the difference between the Value added (% of GDP) in Bosnia and Herzegovina and Value added (% of GDP) in Kazakhstan?
Provide a succinct answer. -4.64. In the year 2003, what is the difference between the Value added (% of GDP) of Bosnia and Herzegovina and Value added (% of GDP) of Kyrgyz Republic?
Make the answer very short. -4.03. In the year 2003, what is the difference between the Value added (% of GDP) in Bosnia and Herzegovina and Value added (% of GDP) in Mexico?
Ensure brevity in your answer.  -7.57. In the year 2003, what is the difference between the Value added (% of GDP) of Kazakhstan and Value added (% of GDP) of Kyrgyz Republic?
Ensure brevity in your answer.  0.62. In the year 2003, what is the difference between the Value added (% of GDP) of Kazakhstan and Value added (% of GDP) of Mexico?
Give a very brief answer. -2.93. In the year 2003, what is the difference between the Value added (% of GDP) of Kyrgyz Republic and Value added (% of GDP) of Mexico?
Your response must be concise. -3.55. In the year 2004, what is the difference between the Value added (% of GDP) of Bosnia and Herzegovina and Value added (% of GDP) of Kazakhstan?
Provide a short and direct response. -2.8. In the year 2004, what is the difference between the Value added (% of GDP) in Bosnia and Herzegovina and Value added (% of GDP) in Kyrgyz Republic?
Provide a succinct answer. -5.68. In the year 2004, what is the difference between the Value added (% of GDP) of Bosnia and Herzegovina and Value added (% of GDP) of Mexico?
Provide a succinct answer. -6.87. In the year 2004, what is the difference between the Value added (% of GDP) of Kazakhstan and Value added (% of GDP) of Kyrgyz Republic?
Keep it short and to the point. -2.89. In the year 2004, what is the difference between the Value added (% of GDP) in Kazakhstan and Value added (% of GDP) in Mexico?
Keep it short and to the point. -4.07. In the year 2004, what is the difference between the Value added (% of GDP) in Kyrgyz Republic and Value added (% of GDP) in Mexico?
Offer a very short reply. -1.19. What is the ratio of the Value added (% of GDP) of Bosnia and Herzegovina in 1998 to that in 1999?
Give a very brief answer. 1.13. What is the ratio of the Value added (% of GDP) of Kazakhstan in 1998 to that in 1999?
Your answer should be compact. 0.86. What is the ratio of the Value added (% of GDP) in Kyrgyz Republic in 1998 to that in 1999?
Make the answer very short. 1.11. What is the ratio of the Value added (% of GDP) of Mexico in 1998 to that in 1999?
Offer a very short reply. 1.03. What is the ratio of the Value added (% of GDP) of Bosnia and Herzegovina in 1998 to that in 2000?
Provide a short and direct response. 1.46. What is the ratio of the Value added (% of GDP) of Kazakhstan in 1998 to that in 2000?
Keep it short and to the point. 0.72. What is the ratio of the Value added (% of GDP) of Kyrgyz Republic in 1998 to that in 2000?
Offer a very short reply. 0.8. What is the ratio of the Value added (% of GDP) of Mexico in 1998 to that in 2000?
Your response must be concise. 1.05. What is the ratio of the Value added (% of GDP) of Bosnia and Herzegovina in 1998 to that in 2001?
Your answer should be very brief. 1.42. What is the ratio of the Value added (% of GDP) in Kazakhstan in 1998 to that in 2001?
Make the answer very short. 0.72. What is the ratio of the Value added (% of GDP) of Kyrgyz Republic in 1998 to that in 2001?
Keep it short and to the point. 0.82. What is the ratio of the Value added (% of GDP) of Mexico in 1998 to that in 2001?
Your answer should be compact. 1.09. What is the ratio of the Value added (% of GDP) of Bosnia and Herzegovina in 1998 to that in 2002?
Keep it short and to the point. 1.43. What is the ratio of the Value added (% of GDP) of Kazakhstan in 1998 to that in 2002?
Your answer should be compact. 0.82. What is the ratio of the Value added (% of GDP) of Kyrgyz Republic in 1998 to that in 2002?
Offer a terse response. 1.08. What is the ratio of the Value added (% of GDP) in Mexico in 1998 to that in 2002?
Your response must be concise. 1.13. What is the ratio of the Value added (% of GDP) in Bosnia and Herzegovina in 1998 to that in 2003?
Ensure brevity in your answer.  1.39. What is the ratio of the Value added (% of GDP) of Kazakhstan in 1998 to that in 2003?
Your response must be concise. 0.84. What is the ratio of the Value added (% of GDP) of Kyrgyz Republic in 1998 to that in 2003?
Offer a terse response. 1.06. What is the ratio of the Value added (% of GDP) of Mexico in 1998 to that in 2003?
Keep it short and to the point. 1.17. What is the ratio of the Value added (% of GDP) in Bosnia and Herzegovina in 1998 to that in 2004?
Provide a succinct answer. 1.29. What is the ratio of the Value added (% of GDP) of Kazakhstan in 1998 to that in 2004?
Your answer should be very brief. 0.9. What is the ratio of the Value added (% of GDP) of Kyrgyz Republic in 1998 to that in 2004?
Offer a terse response. 0.91. What is the ratio of the Value added (% of GDP) of Mexico in 1998 to that in 2004?
Give a very brief answer. 1.16. What is the ratio of the Value added (% of GDP) in Bosnia and Herzegovina in 1999 to that in 2000?
Offer a very short reply. 1.29. What is the ratio of the Value added (% of GDP) of Kazakhstan in 1999 to that in 2000?
Provide a short and direct response. 0.85. What is the ratio of the Value added (% of GDP) in Kyrgyz Republic in 1999 to that in 2000?
Make the answer very short. 0.72. What is the ratio of the Value added (% of GDP) of Mexico in 1999 to that in 2000?
Make the answer very short. 1.02. What is the ratio of the Value added (% of GDP) of Bosnia and Herzegovina in 1999 to that in 2001?
Give a very brief answer. 1.26. What is the ratio of the Value added (% of GDP) in Kazakhstan in 1999 to that in 2001?
Provide a succinct answer. 0.85. What is the ratio of the Value added (% of GDP) of Kyrgyz Republic in 1999 to that in 2001?
Your answer should be very brief. 0.74. What is the ratio of the Value added (% of GDP) of Mexico in 1999 to that in 2001?
Offer a terse response. 1.07. What is the ratio of the Value added (% of GDP) of Bosnia and Herzegovina in 1999 to that in 2002?
Your answer should be very brief. 1.27. What is the ratio of the Value added (% of GDP) in Kazakhstan in 1999 to that in 2002?
Offer a very short reply. 0.96. What is the ratio of the Value added (% of GDP) of Kyrgyz Republic in 1999 to that in 2002?
Keep it short and to the point. 0.98. What is the ratio of the Value added (% of GDP) in Mexico in 1999 to that in 2002?
Your response must be concise. 1.1. What is the ratio of the Value added (% of GDP) in Bosnia and Herzegovina in 1999 to that in 2003?
Keep it short and to the point. 1.23. What is the ratio of the Value added (% of GDP) in Kazakhstan in 1999 to that in 2003?
Your answer should be very brief. 0.98. What is the ratio of the Value added (% of GDP) in Kyrgyz Republic in 1999 to that in 2003?
Your response must be concise. 0.96. What is the ratio of the Value added (% of GDP) in Mexico in 1999 to that in 2003?
Your answer should be very brief. 1.14. What is the ratio of the Value added (% of GDP) in Bosnia and Herzegovina in 1999 to that in 2004?
Your answer should be very brief. 1.15. What is the ratio of the Value added (% of GDP) in Kazakhstan in 1999 to that in 2004?
Provide a short and direct response. 1.05. What is the ratio of the Value added (% of GDP) in Kyrgyz Republic in 1999 to that in 2004?
Your response must be concise. 0.82. What is the ratio of the Value added (% of GDP) in Mexico in 1999 to that in 2004?
Your response must be concise. 1.13. What is the ratio of the Value added (% of GDP) of Bosnia and Herzegovina in 2000 to that in 2001?
Keep it short and to the point. 0.97. What is the ratio of the Value added (% of GDP) of Kazakhstan in 2000 to that in 2001?
Provide a succinct answer. 1. What is the ratio of the Value added (% of GDP) of Kyrgyz Republic in 2000 to that in 2001?
Offer a terse response. 1.02. What is the ratio of the Value added (% of GDP) in Mexico in 2000 to that in 2001?
Ensure brevity in your answer.  1.05. What is the ratio of the Value added (% of GDP) of Bosnia and Herzegovina in 2000 to that in 2002?
Provide a succinct answer. 0.99. What is the ratio of the Value added (% of GDP) of Kazakhstan in 2000 to that in 2002?
Give a very brief answer. 1.13. What is the ratio of the Value added (% of GDP) in Kyrgyz Republic in 2000 to that in 2002?
Offer a very short reply. 1.36. What is the ratio of the Value added (% of GDP) in Mexico in 2000 to that in 2002?
Offer a very short reply. 1.08. What is the ratio of the Value added (% of GDP) in Bosnia and Herzegovina in 2000 to that in 2003?
Your answer should be very brief. 0.95. What is the ratio of the Value added (% of GDP) of Kazakhstan in 2000 to that in 2003?
Keep it short and to the point. 1.16. What is the ratio of the Value added (% of GDP) in Kyrgyz Republic in 2000 to that in 2003?
Your response must be concise. 1.33. What is the ratio of the Value added (% of GDP) of Mexico in 2000 to that in 2003?
Keep it short and to the point. 1.12. What is the ratio of the Value added (% of GDP) in Bosnia and Herzegovina in 2000 to that in 2004?
Ensure brevity in your answer.  0.89. What is the ratio of the Value added (% of GDP) of Kazakhstan in 2000 to that in 2004?
Your answer should be very brief. 1.25. What is the ratio of the Value added (% of GDP) in Kyrgyz Republic in 2000 to that in 2004?
Provide a succinct answer. 1.14. What is the ratio of the Value added (% of GDP) in Mexico in 2000 to that in 2004?
Provide a short and direct response. 1.11. What is the ratio of the Value added (% of GDP) in Bosnia and Herzegovina in 2001 to that in 2002?
Provide a short and direct response. 1.01. What is the ratio of the Value added (% of GDP) of Kazakhstan in 2001 to that in 2002?
Your answer should be very brief. 1.13. What is the ratio of the Value added (% of GDP) of Kyrgyz Republic in 2001 to that in 2002?
Your answer should be compact. 1.33. What is the ratio of the Value added (% of GDP) of Mexico in 2001 to that in 2002?
Your response must be concise. 1.03. What is the ratio of the Value added (% of GDP) of Bosnia and Herzegovina in 2001 to that in 2003?
Provide a succinct answer. 0.98. What is the ratio of the Value added (% of GDP) in Kazakhstan in 2001 to that in 2003?
Offer a terse response. 1.16. What is the ratio of the Value added (% of GDP) in Kyrgyz Republic in 2001 to that in 2003?
Offer a terse response. 1.3. What is the ratio of the Value added (% of GDP) of Mexico in 2001 to that in 2003?
Offer a very short reply. 1.07. What is the ratio of the Value added (% of GDP) of Bosnia and Herzegovina in 2001 to that in 2004?
Keep it short and to the point. 0.91. What is the ratio of the Value added (% of GDP) of Kazakhstan in 2001 to that in 2004?
Ensure brevity in your answer.  1.25. What is the ratio of the Value added (% of GDP) in Kyrgyz Republic in 2001 to that in 2004?
Your answer should be compact. 1.12. What is the ratio of the Value added (% of GDP) of Mexico in 2001 to that in 2004?
Provide a short and direct response. 1.06. What is the ratio of the Value added (% of GDP) in Bosnia and Herzegovina in 2002 to that in 2003?
Offer a terse response. 0.97. What is the ratio of the Value added (% of GDP) in Kazakhstan in 2002 to that in 2003?
Your answer should be compact. 1.02. What is the ratio of the Value added (% of GDP) of Kyrgyz Republic in 2002 to that in 2003?
Make the answer very short. 0.98. What is the ratio of the Value added (% of GDP) of Mexico in 2002 to that in 2003?
Provide a succinct answer. 1.04. What is the ratio of the Value added (% of GDP) in Bosnia and Herzegovina in 2002 to that in 2004?
Offer a very short reply. 0.9. What is the ratio of the Value added (% of GDP) of Kazakhstan in 2002 to that in 2004?
Your answer should be very brief. 1.1. What is the ratio of the Value added (% of GDP) of Kyrgyz Republic in 2002 to that in 2004?
Offer a terse response. 0.84. What is the ratio of the Value added (% of GDP) of Mexico in 2002 to that in 2004?
Give a very brief answer. 1.03. What is the ratio of the Value added (% of GDP) of Bosnia and Herzegovina in 2003 to that in 2004?
Your answer should be very brief. 0.93. What is the ratio of the Value added (% of GDP) in Kazakhstan in 2003 to that in 2004?
Offer a very short reply. 1.08. What is the ratio of the Value added (% of GDP) in Kyrgyz Republic in 2003 to that in 2004?
Offer a very short reply. 0.86. What is the difference between the highest and the second highest Value added (% of GDP) in Bosnia and Herzegovina?
Your answer should be compact. 1.67. What is the difference between the highest and the second highest Value added (% of GDP) of Kazakhstan?
Keep it short and to the point. 0.02. What is the difference between the highest and the second highest Value added (% of GDP) in Kyrgyz Republic?
Give a very brief answer. 0.44. What is the difference between the highest and the second highest Value added (% of GDP) in Mexico?
Your answer should be compact. 0.54. What is the difference between the highest and the lowest Value added (% of GDP) in Bosnia and Herzegovina?
Your answer should be compact. 4.6. What is the difference between the highest and the lowest Value added (% of GDP) of Kazakhstan?
Keep it short and to the point. 4.88. What is the difference between the highest and the lowest Value added (% of GDP) of Kyrgyz Republic?
Make the answer very short. 5.45. What is the difference between the highest and the lowest Value added (% of GDP) in Mexico?
Give a very brief answer. 3.04. 